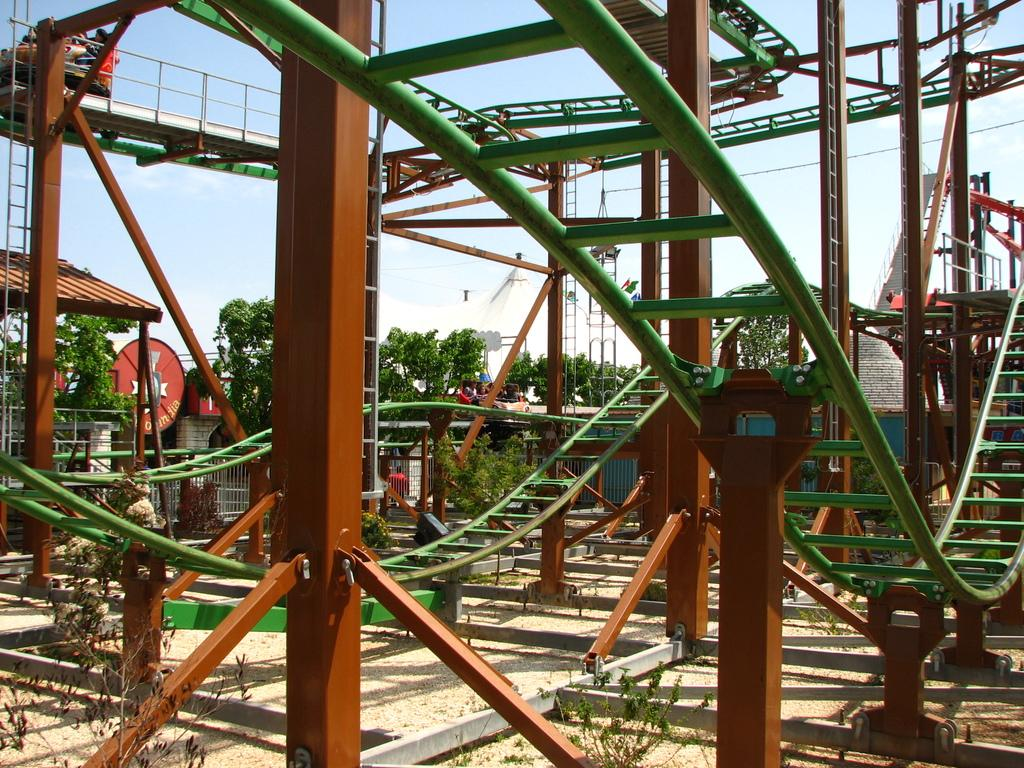What is the main subject of the picture? The main subject of the picture is a mini roller coaster. What can be seen in the background of the picture? There are trees and the sky visible in the background of the picture. How many mice are riding the mini roller coaster in the image? There are no mice present in the image, and therefore no mice are riding the mini roller coaster. What fact can be determined about the roller coaster's height from the image? The image does not provide enough information to determine the height of the mini roller coaster. 